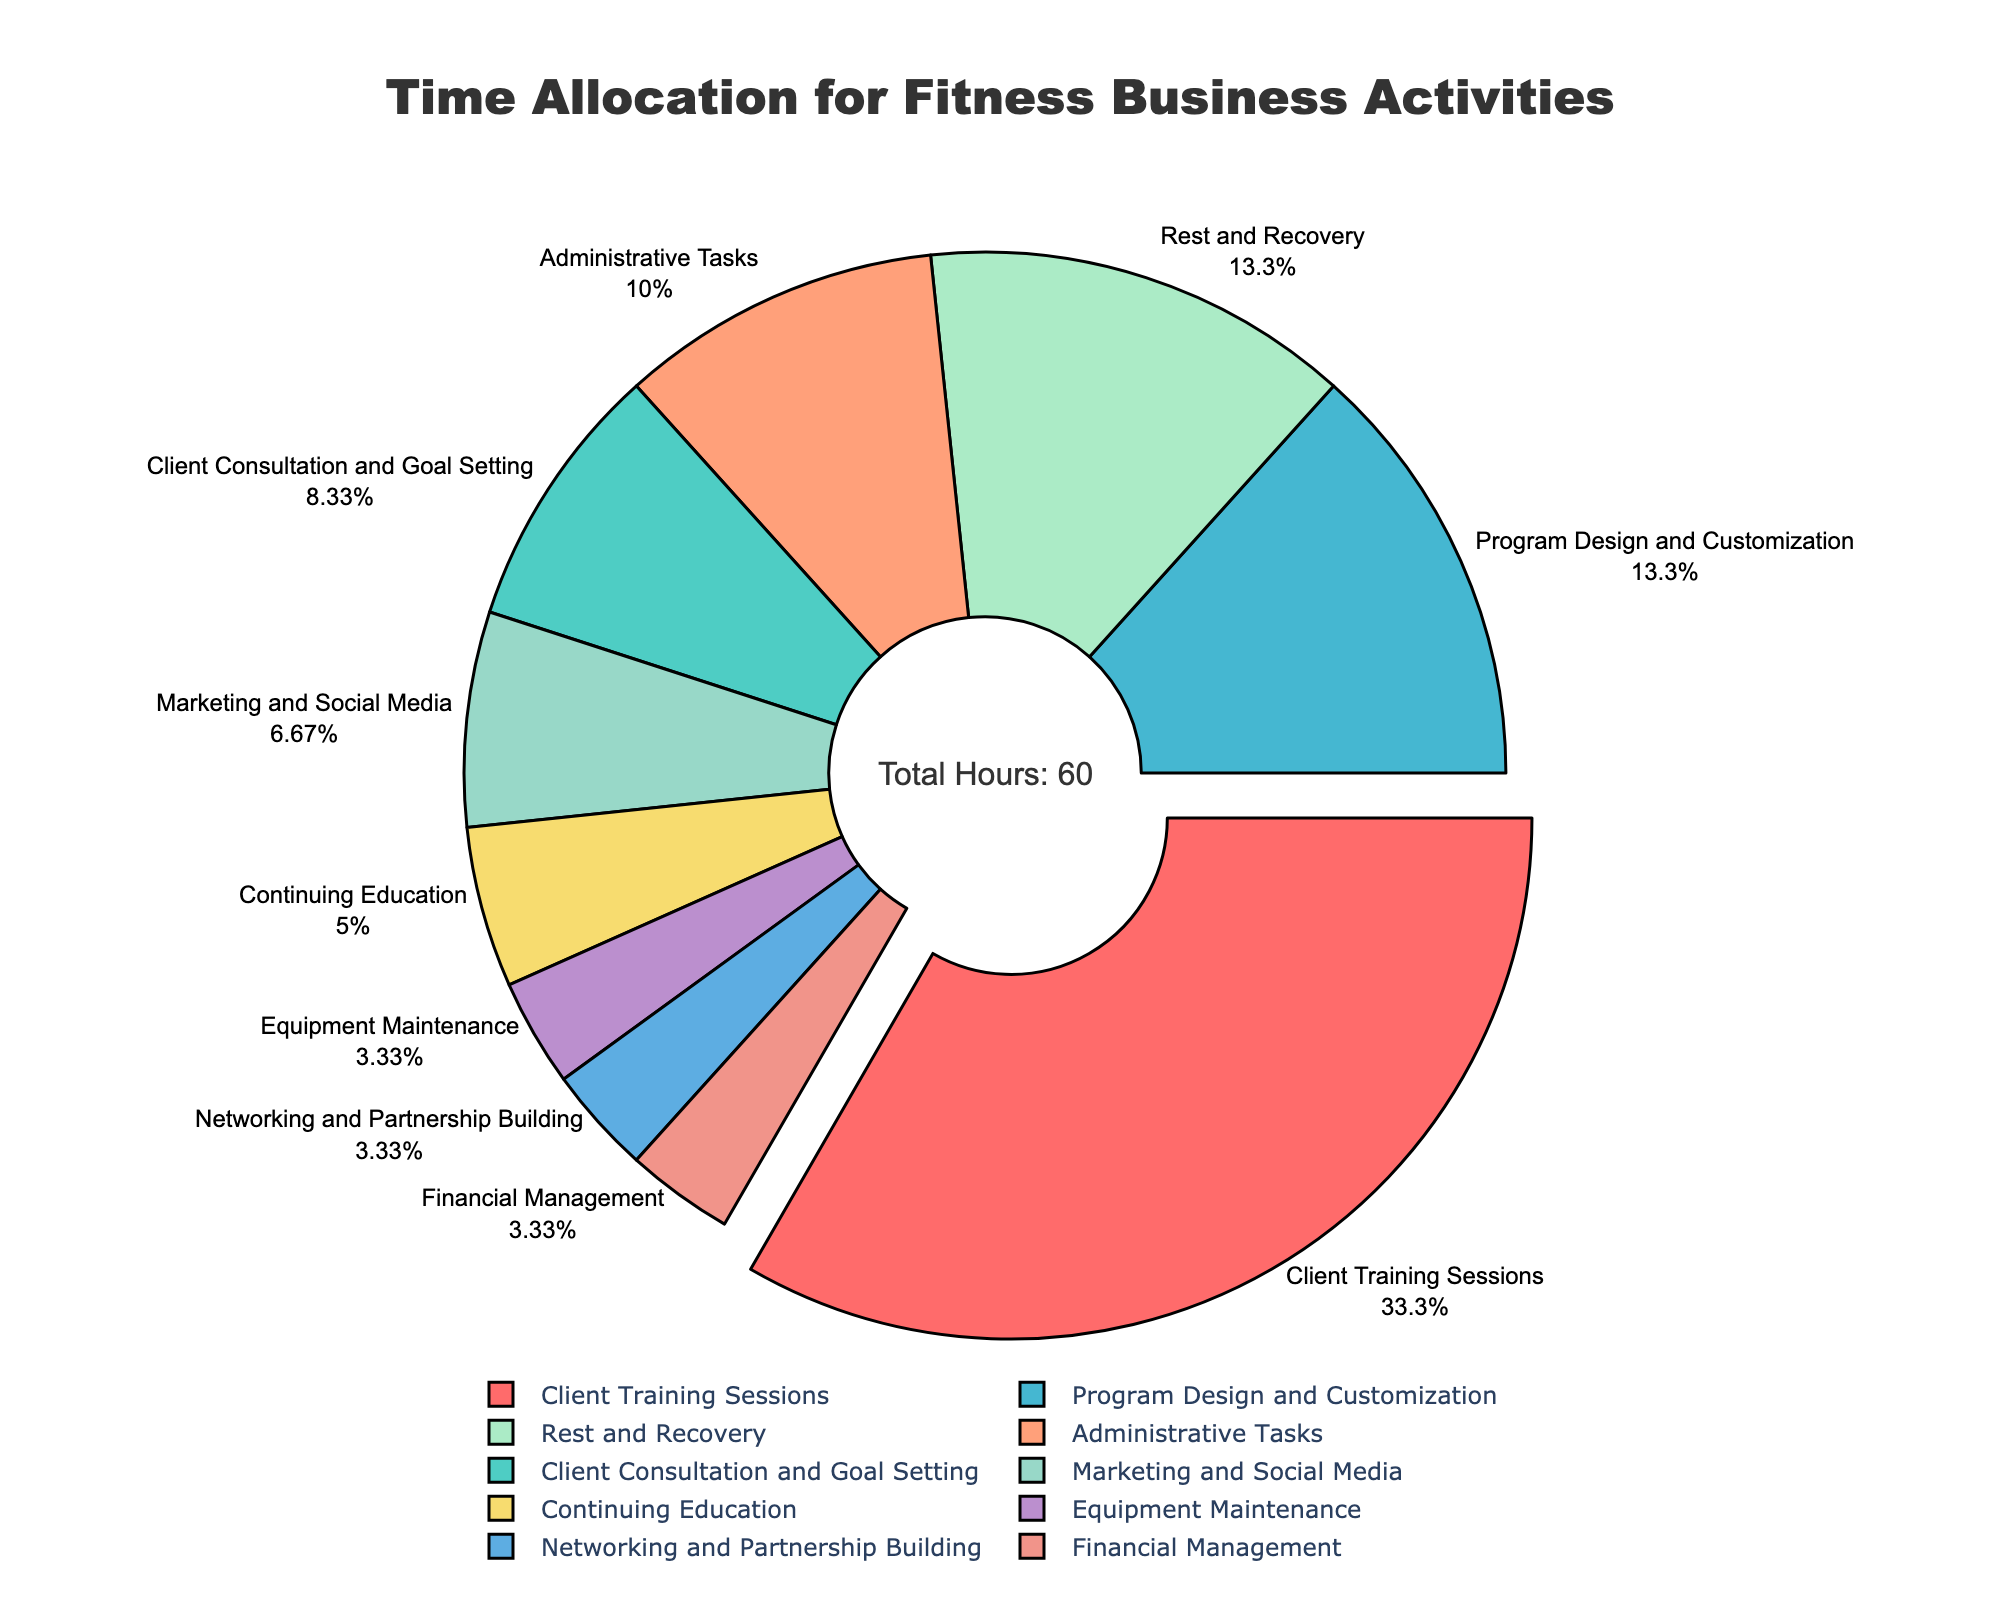Which activity takes up the most time per week? The visual shows that "Client Training Sessions" takes up the largest portion of the pie chart. It is the segment pulled outward and labeled with the highest value.
Answer: Client Training Sessions How much more time is spent on "Client Training Sessions" compared to "Marketing and Social Media"? "Client Training Sessions" occupies 20 hours per week, while "Marketing and Social Media" takes 4 hours per week. The difference is 20 - 4 = 16 hours.
Answer: 16 hours Which activities take the same amount of time per week? "Equipment Maintenance," "Networking and Partnership Building," and "Financial Management" each take up 2 hours per week, as shown by their equally sized segments in the pie chart.
Answer: Equipment Maintenance, Networking and Partnership Building, Financial Management What percentage of the total time is allocated to "Rest and Recovery"? The figure's "Rest and Recovery" segment shows that it takes 8 hours per week. To find the percentage: (8 / 60) * 100 ≈ 13.33%.
Answer: 13.33% How much time is collectively spent on "Administrative Tasks" and "Continuing Education"? "Administrative Tasks" takes 6 hours, and "Continuing Education" takes 3 hours. The total is 6 + 3 = 9 hours.
Answer: 9 hours What is the ratio of time spent on "Program Design and Customization" to "Client Consultation and Goal Setting"? "Program Design and Customization" takes 8 hours, and "Client Consultation and Goal Setting" takes 5 hours. The ratio is 8:5 or simplified, 8/5 = 1.6.
Answer: 1.6 How much more time is spent on "Client Consultation and Goal Setting" than on "Networking and Partnership Building"? "Client Consultation and Goal Setting" takes 5 hours, while "Networking and Partnership Building" takes 2 hours. The difference is 5 - 2 = 3 hours.
Answer: 3 hours Which activity is associated with the orange color in the chart? By visual inspection, the orange segment corresponds to "Client Consultation and Goal Setting."
Answer: Client Consultation and Goal Setting 